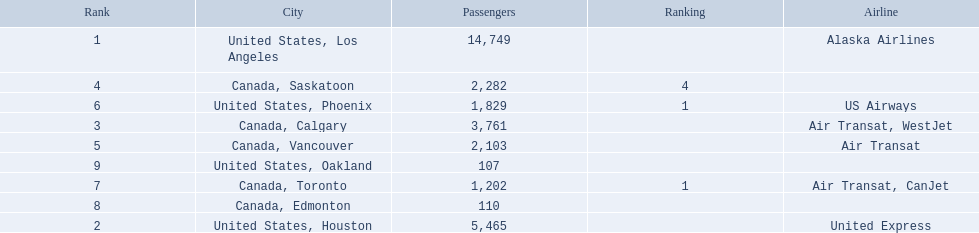What are the cities that are associated with the playa de oro international airport? United States, Los Angeles, United States, Houston, Canada, Calgary, Canada, Saskatoon, Canada, Vancouver, United States, Phoenix, Canada, Toronto, Canada, Edmonton, United States, Oakland. What is uniteed states, los angeles passenger count? 14,749. What other cities passenger count would lead to 19,000 roughly when combined with previous los angeles? Canada, Calgary. 